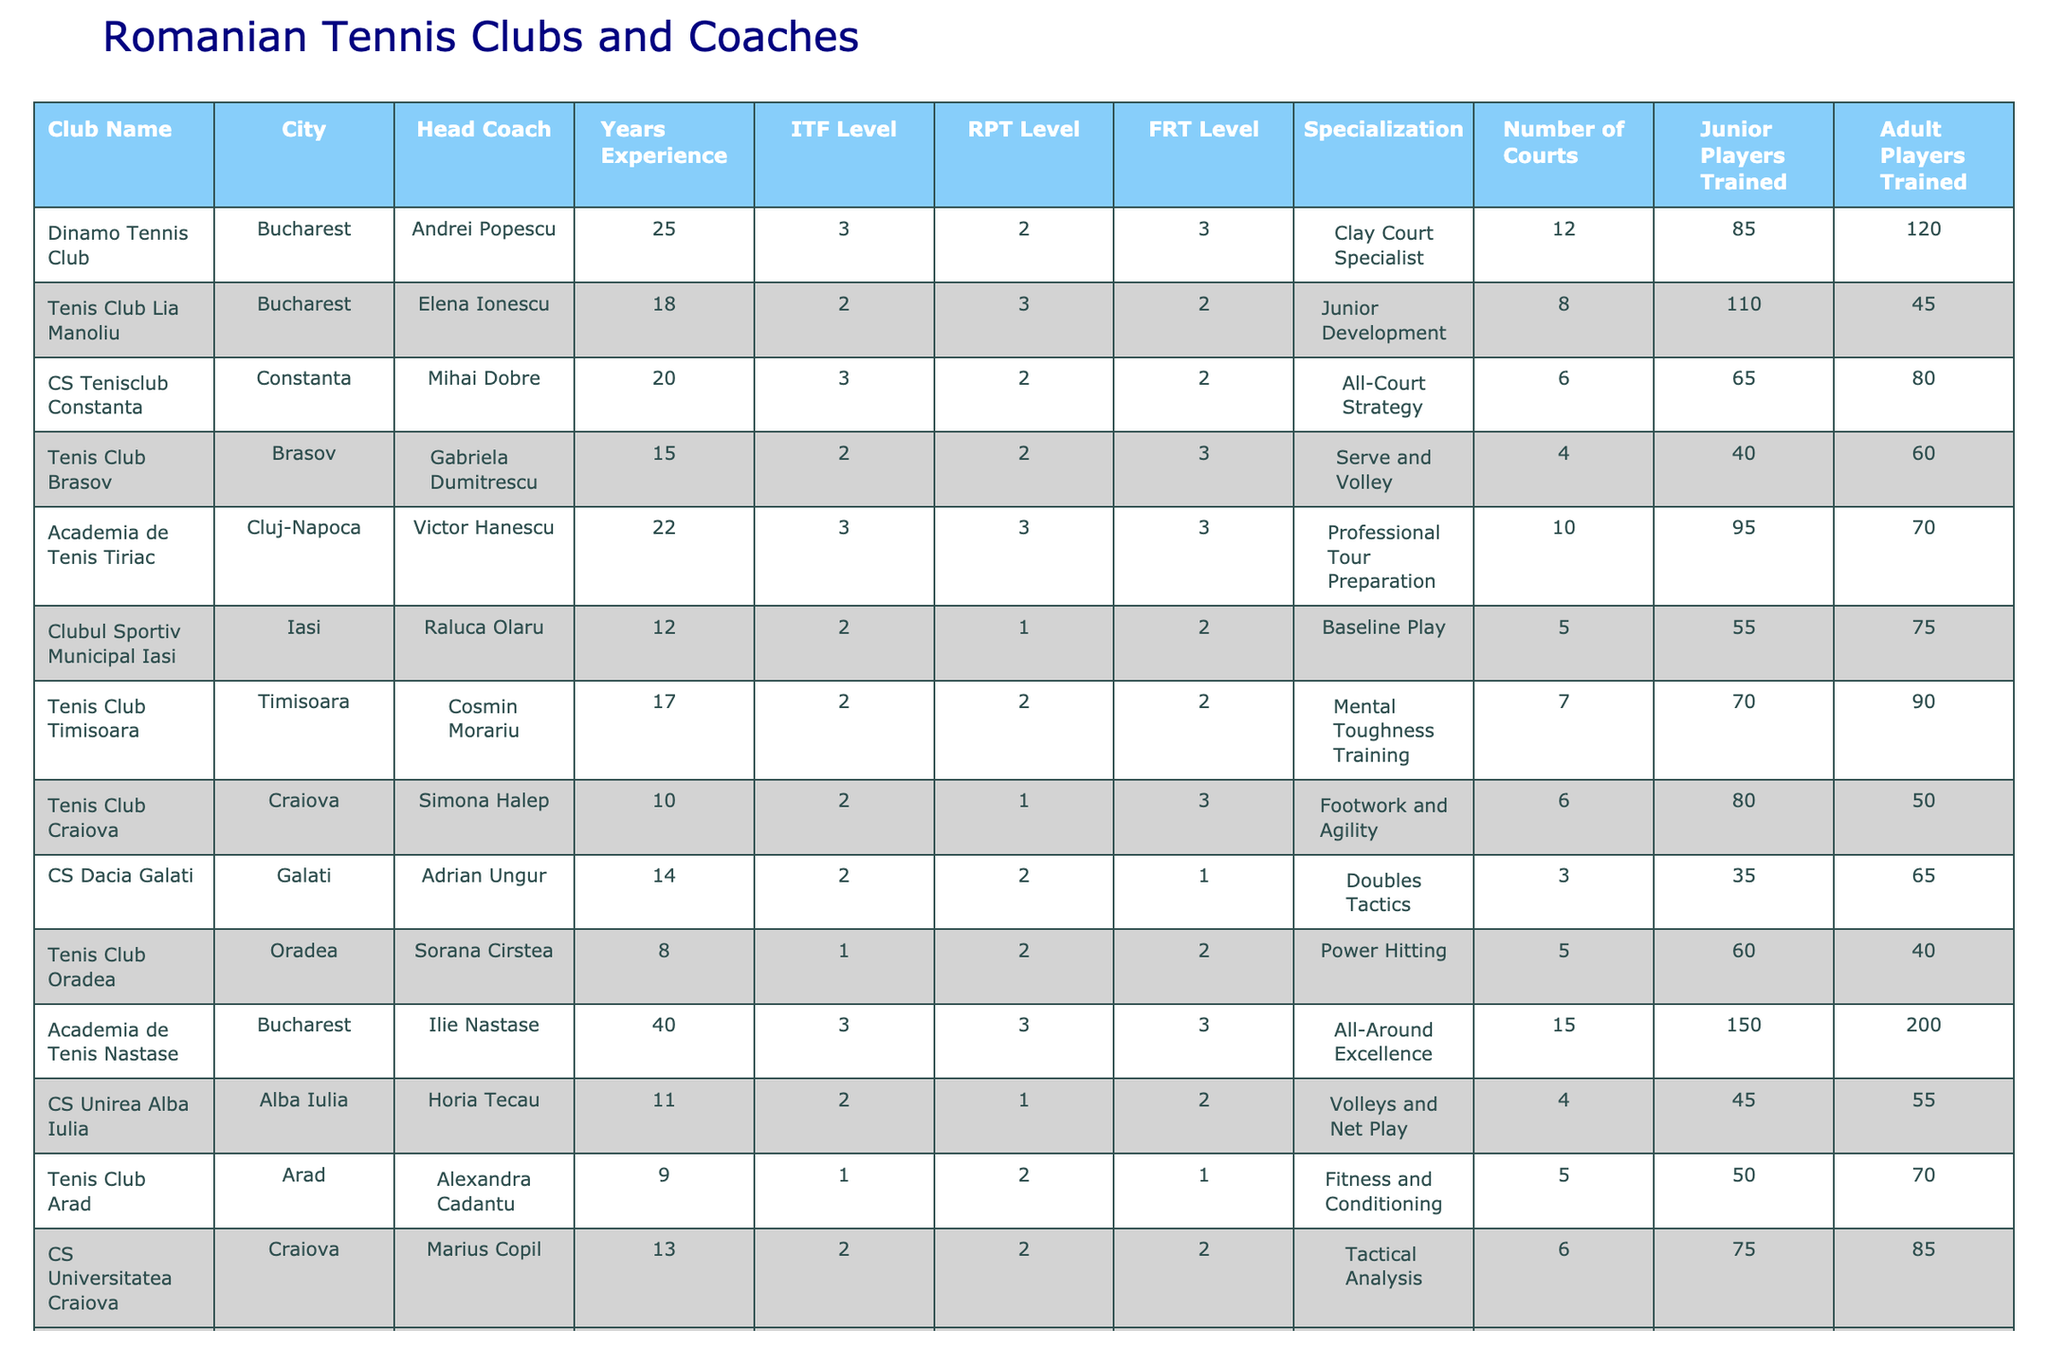What is the head coach's name at Dinamo Tennis Club? The table indicates that the head coach at Dinamo Tennis Club is Andrei Popescu.
Answer: Andrei Popescu How many years of experience does Gabriela Dumitrescu have? Looking at the table, Gabriela Dumitrescu has 15 years of experience as a tennis coach.
Answer: 15 years Which club has the highest number of junior players trained? By examining the table, it's clear that Academia de Tenis Nastase has trained the highest number of junior players at 150.
Answer: Academia de Tenis Nastase How many adult players has Horia Tecau trained? According to the table, Horia Tecau has trained 55 adult players.
Answer: 55 What is the average number of courts across all clubs? To find the average, sum the number of courts (12 + 8 + 6 + 4 + 10 + 5 + 7 + 6 + 3 + 5 + 15 + 4 + 5 + 6 + 4 =  75) and divide by the number of clubs (15). The average is 75 / 15 = 5.
Answer: 5 Is there a coach with an ITF Level of 1? The table confirms that Sorana Cirstea and Alexandra Cadantu both have an ITF Level of 1, making the statement true.
Answer: Yes Who is the most experienced coach listed in the table? By analyzing the years of experience column, Ilie Nastase is the most experienced coach with 40 years.
Answer: Ilie Nastase What specialization does Simona Halep focus on? The table specifies that Simona Halep specializes in Footwork and Agility.
Answer: Footwork and Agility How many junior players were trained in total by the clubs in Iasi? Only CS Unirea Alba Iulia and Clubul Sportiv Municipal Iasi are in Iasi; they trained a total of 55 (CS Unirea Alba Iulia) + 55 (Clubul Sportiv Municipal Iasi) = 100 junior players in total.
Answer: 100 Is CS Tenisclub Constanta more focused on junior training or adult training? The table shows that CS Tenisclub Constanta has trained 65 junior players and 80 adult players, indicating it focuses more on adult training.
Answer: Adult training What is the difference in the number of courts between Tenis Club Arad and Academia de Tenis Tiriac? Tenis Club Arad has 5 courts and Academia de Tenis Tiriac has 10 courts. The difference is 10 - 5 = 5 courts.
Answer: 5 courts 